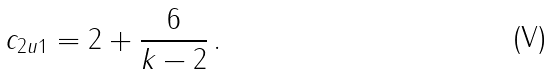<formula> <loc_0><loc_0><loc_500><loc_500>c _ { \sl 2 u 1 } = 2 + \frac { 6 } { k - 2 } \, .</formula> 